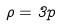Convert formula to latex. <formula><loc_0><loc_0><loc_500><loc_500>\rho = 3 p</formula> 